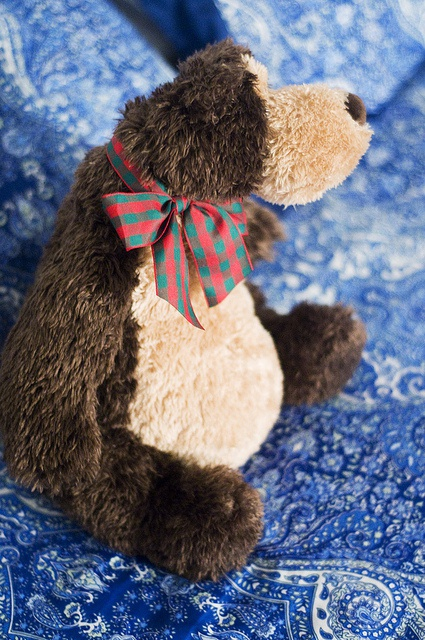Describe the objects in this image and their specific colors. I can see bed in blue, darkgray, navy, and gray tones and teddy bear in blue, black, lightgray, and tan tones in this image. 